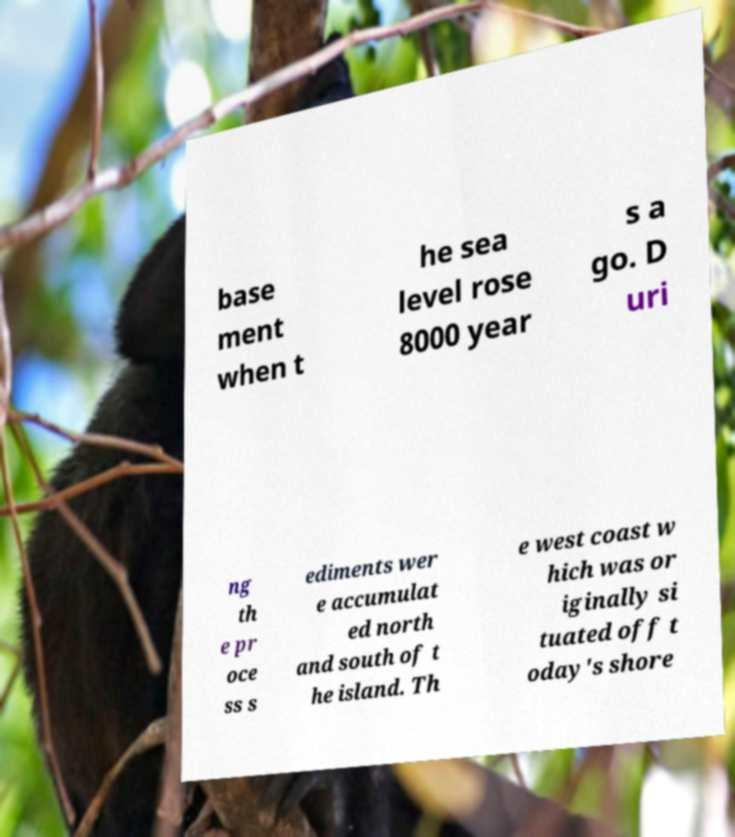I need the written content from this picture converted into text. Can you do that? base ment when t he sea level rose 8000 year s a go. D uri ng th e pr oce ss s ediments wer e accumulat ed north and south of t he island. Th e west coast w hich was or iginally si tuated off t oday's shore 